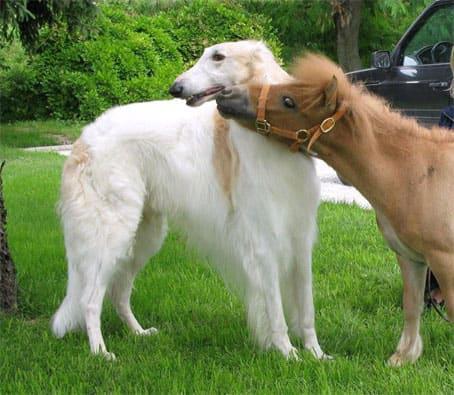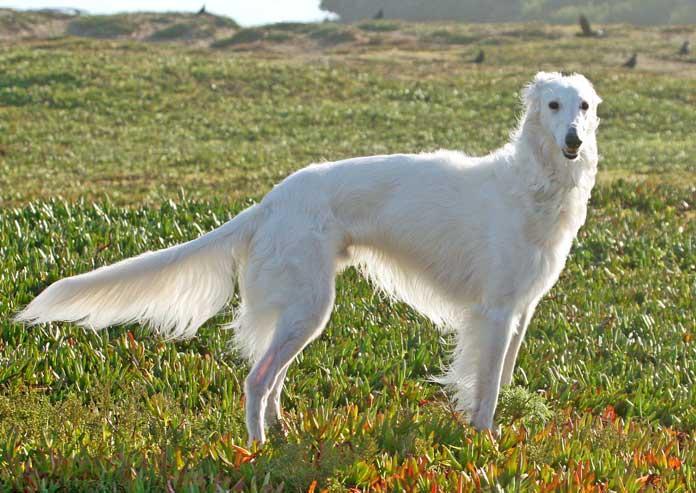The first image is the image on the left, the second image is the image on the right. Considering the images on both sides, is "One of the images contains exactly two dogs." valid? Answer yes or no. No. 